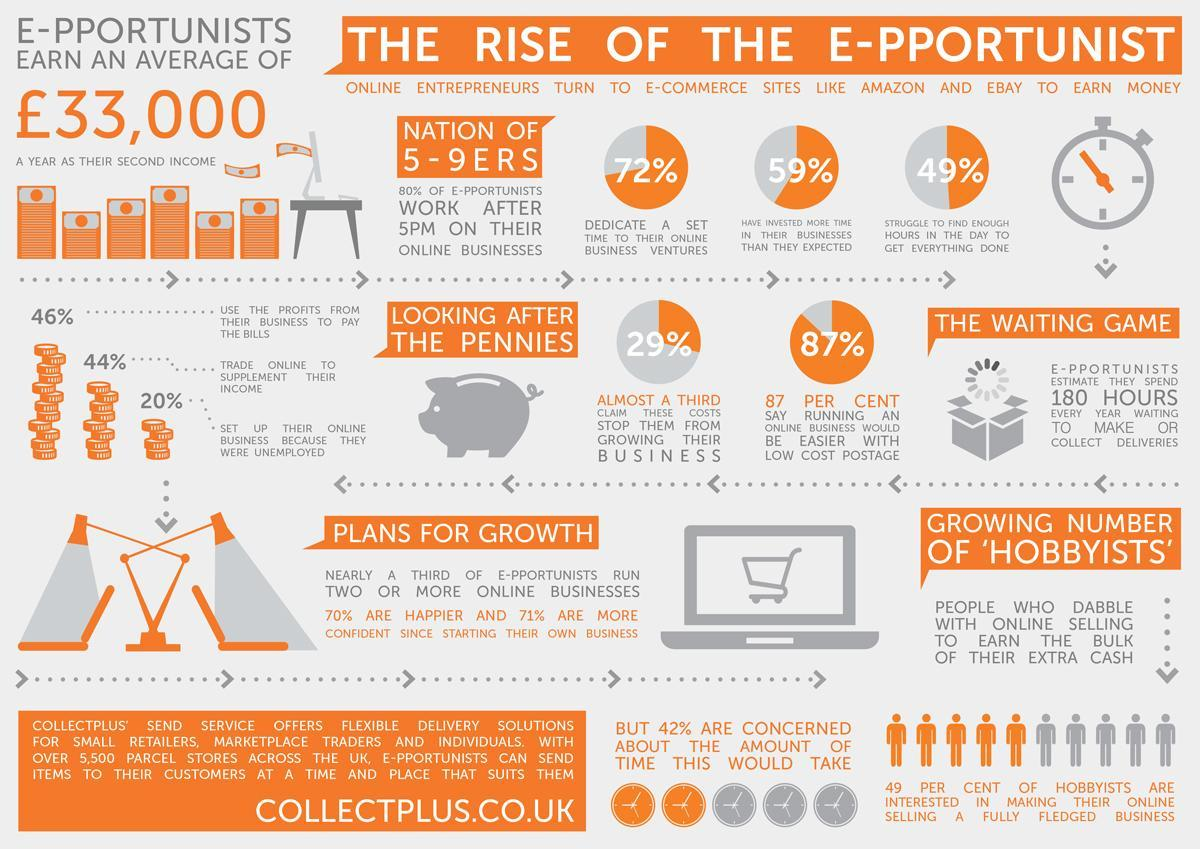What percentage of E-pportunists in UK have invested more time in their business than they expected?
Answer the question with a short phrase. 59% What percentage of E-pportunists in UK trade online to supplement their income? 44% What is the average earning of E-pportunists in UK per year? £33,000 What percentage of E-pportunists in UK struggle to find enough hours in the day to get everything done? 49% What percentage of E-pportunists in UK dedicate a set time to their online business ventures? 72% 